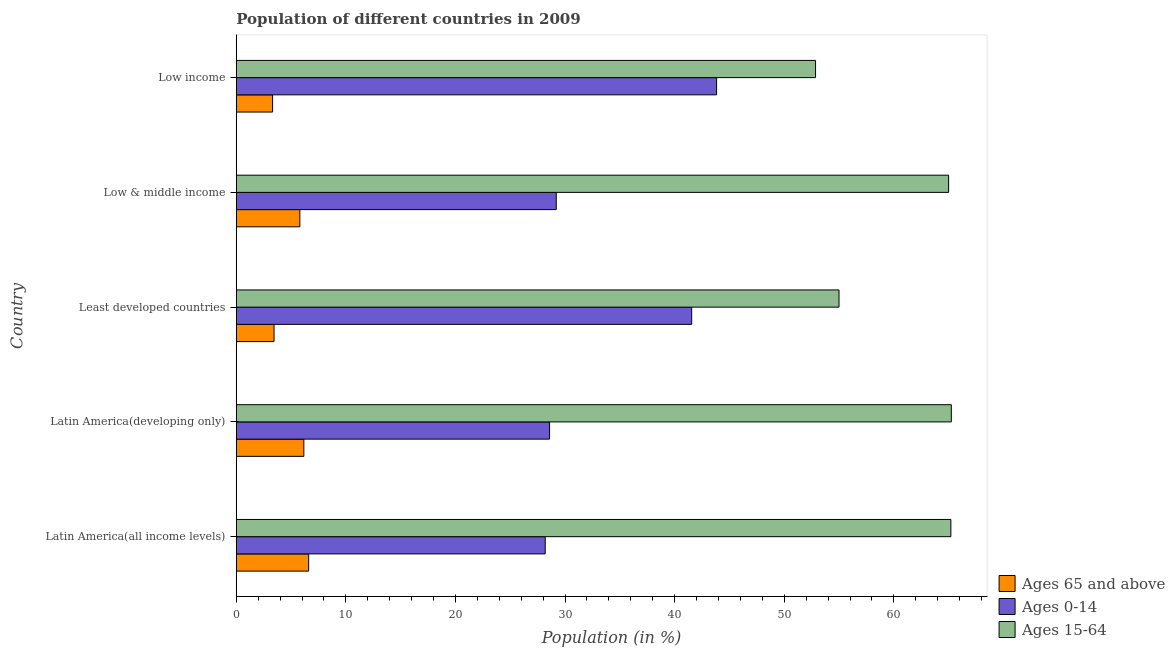Are the number of bars per tick equal to the number of legend labels?
Your answer should be compact. Yes. How many bars are there on the 3rd tick from the bottom?
Provide a short and direct response. 3. What is the label of the 5th group of bars from the top?
Your answer should be very brief. Latin America(all income levels). What is the percentage of population within the age-group 15-64 in Latin America(all income levels)?
Your answer should be compact. 65.2. Across all countries, what is the maximum percentage of population within the age-group 15-64?
Provide a succinct answer. 65.24. Across all countries, what is the minimum percentage of population within the age-group of 65 and above?
Offer a very short reply. 3.32. In which country was the percentage of population within the age-group 15-64 minimum?
Make the answer very short. Low income. What is the total percentage of population within the age-group 0-14 in the graph?
Your answer should be compact. 171.36. What is the difference between the percentage of population within the age-group 0-14 in Latin America(developing only) and that in Low income?
Ensure brevity in your answer.  -15.24. What is the difference between the percentage of population within the age-group 15-64 in Low & middle income and the percentage of population within the age-group of 65 and above in Latin America(developing only)?
Offer a very short reply. 58.83. What is the average percentage of population within the age-group 0-14 per country?
Offer a terse response. 34.27. What is the difference between the percentage of population within the age-group 0-14 and percentage of population within the age-group 15-64 in Latin America(all income levels)?
Make the answer very short. -37.01. What is the ratio of the percentage of population within the age-group 0-14 in Least developed countries to that in Low & middle income?
Provide a succinct answer. 1.42. Is the percentage of population within the age-group 0-14 in Latin America(all income levels) less than that in Low income?
Ensure brevity in your answer.  Yes. Is the difference between the percentage of population within the age-group of 65 and above in Latin America(developing only) and Low income greater than the difference between the percentage of population within the age-group 15-64 in Latin America(developing only) and Low income?
Keep it short and to the point. No. What is the difference between the highest and the second highest percentage of population within the age-group of 65 and above?
Keep it short and to the point. 0.44. What is the difference between the highest and the lowest percentage of population within the age-group of 65 and above?
Your answer should be very brief. 3.29. In how many countries, is the percentage of population within the age-group 15-64 greater than the average percentage of population within the age-group 15-64 taken over all countries?
Your answer should be very brief. 3. What does the 2nd bar from the top in Latin America(developing only) represents?
Give a very brief answer. Ages 0-14. What does the 1st bar from the bottom in Least developed countries represents?
Your response must be concise. Ages 65 and above. How many bars are there?
Your answer should be very brief. 15. Are all the bars in the graph horizontal?
Provide a succinct answer. Yes. How many countries are there in the graph?
Keep it short and to the point. 5. Does the graph contain any zero values?
Your answer should be compact. No. Where does the legend appear in the graph?
Offer a very short reply. Bottom right. What is the title of the graph?
Provide a succinct answer. Population of different countries in 2009. Does "Social insurance" appear as one of the legend labels in the graph?
Provide a short and direct response. No. What is the label or title of the X-axis?
Provide a short and direct response. Population (in %). What is the label or title of the Y-axis?
Offer a terse response. Country. What is the Population (in %) of Ages 65 and above in Latin America(all income levels)?
Keep it short and to the point. 6.61. What is the Population (in %) in Ages 0-14 in Latin America(all income levels)?
Give a very brief answer. 28.19. What is the Population (in %) in Ages 15-64 in Latin America(all income levels)?
Make the answer very short. 65.2. What is the Population (in %) in Ages 65 and above in Latin America(developing only)?
Offer a terse response. 6.17. What is the Population (in %) of Ages 0-14 in Latin America(developing only)?
Make the answer very short. 28.59. What is the Population (in %) of Ages 15-64 in Latin America(developing only)?
Provide a succinct answer. 65.24. What is the Population (in %) of Ages 65 and above in Least developed countries?
Offer a terse response. 3.45. What is the Population (in %) of Ages 0-14 in Least developed countries?
Offer a very short reply. 41.55. What is the Population (in %) of Ages 15-64 in Least developed countries?
Ensure brevity in your answer.  55. What is the Population (in %) in Ages 65 and above in Low & middle income?
Provide a short and direct response. 5.8. What is the Population (in %) in Ages 0-14 in Low & middle income?
Make the answer very short. 29.2. What is the Population (in %) of Ages 15-64 in Low & middle income?
Give a very brief answer. 65. What is the Population (in %) of Ages 65 and above in Low income?
Make the answer very short. 3.32. What is the Population (in %) in Ages 0-14 in Low income?
Ensure brevity in your answer.  43.83. What is the Population (in %) in Ages 15-64 in Low income?
Provide a short and direct response. 52.86. Across all countries, what is the maximum Population (in %) of Ages 65 and above?
Ensure brevity in your answer.  6.61. Across all countries, what is the maximum Population (in %) of Ages 0-14?
Ensure brevity in your answer.  43.83. Across all countries, what is the maximum Population (in %) of Ages 15-64?
Provide a short and direct response. 65.24. Across all countries, what is the minimum Population (in %) of Ages 65 and above?
Your answer should be compact. 3.32. Across all countries, what is the minimum Population (in %) in Ages 0-14?
Your answer should be compact. 28.19. Across all countries, what is the minimum Population (in %) in Ages 15-64?
Keep it short and to the point. 52.86. What is the total Population (in %) in Ages 65 and above in the graph?
Keep it short and to the point. 25.34. What is the total Population (in %) of Ages 0-14 in the graph?
Make the answer very short. 171.36. What is the total Population (in %) of Ages 15-64 in the graph?
Make the answer very short. 303.3. What is the difference between the Population (in %) of Ages 65 and above in Latin America(all income levels) and that in Latin America(developing only)?
Make the answer very short. 0.44. What is the difference between the Population (in %) of Ages 0-14 in Latin America(all income levels) and that in Latin America(developing only)?
Provide a short and direct response. -0.4. What is the difference between the Population (in %) of Ages 15-64 in Latin America(all income levels) and that in Latin America(developing only)?
Your answer should be compact. -0.04. What is the difference between the Population (in %) in Ages 65 and above in Latin America(all income levels) and that in Least developed countries?
Your response must be concise. 3.16. What is the difference between the Population (in %) of Ages 0-14 in Latin America(all income levels) and that in Least developed countries?
Your response must be concise. -13.36. What is the difference between the Population (in %) in Ages 15-64 in Latin America(all income levels) and that in Least developed countries?
Your response must be concise. 10.2. What is the difference between the Population (in %) in Ages 65 and above in Latin America(all income levels) and that in Low & middle income?
Your answer should be very brief. 0.8. What is the difference between the Population (in %) in Ages 0-14 in Latin America(all income levels) and that in Low & middle income?
Keep it short and to the point. -1.01. What is the difference between the Population (in %) in Ages 15-64 in Latin America(all income levels) and that in Low & middle income?
Keep it short and to the point. 0.2. What is the difference between the Population (in %) in Ages 65 and above in Latin America(all income levels) and that in Low income?
Give a very brief answer. 3.29. What is the difference between the Population (in %) in Ages 0-14 in Latin America(all income levels) and that in Low income?
Ensure brevity in your answer.  -15.64. What is the difference between the Population (in %) of Ages 15-64 in Latin America(all income levels) and that in Low income?
Make the answer very short. 12.35. What is the difference between the Population (in %) in Ages 65 and above in Latin America(developing only) and that in Least developed countries?
Keep it short and to the point. 2.72. What is the difference between the Population (in %) of Ages 0-14 in Latin America(developing only) and that in Least developed countries?
Provide a succinct answer. -12.97. What is the difference between the Population (in %) in Ages 15-64 in Latin America(developing only) and that in Least developed countries?
Offer a terse response. 10.25. What is the difference between the Population (in %) in Ages 65 and above in Latin America(developing only) and that in Low & middle income?
Give a very brief answer. 0.37. What is the difference between the Population (in %) of Ages 0-14 in Latin America(developing only) and that in Low & middle income?
Your answer should be compact. -0.61. What is the difference between the Population (in %) of Ages 15-64 in Latin America(developing only) and that in Low & middle income?
Provide a short and direct response. 0.25. What is the difference between the Population (in %) of Ages 65 and above in Latin America(developing only) and that in Low income?
Provide a succinct answer. 2.85. What is the difference between the Population (in %) in Ages 0-14 in Latin America(developing only) and that in Low income?
Offer a very short reply. -15.24. What is the difference between the Population (in %) in Ages 15-64 in Latin America(developing only) and that in Low income?
Ensure brevity in your answer.  12.39. What is the difference between the Population (in %) of Ages 65 and above in Least developed countries and that in Low & middle income?
Provide a short and direct response. -2.35. What is the difference between the Population (in %) of Ages 0-14 in Least developed countries and that in Low & middle income?
Offer a very short reply. 12.36. What is the difference between the Population (in %) in Ages 15-64 in Least developed countries and that in Low & middle income?
Provide a succinct answer. -10. What is the difference between the Population (in %) of Ages 65 and above in Least developed countries and that in Low income?
Ensure brevity in your answer.  0.13. What is the difference between the Population (in %) in Ages 0-14 in Least developed countries and that in Low income?
Offer a very short reply. -2.27. What is the difference between the Population (in %) of Ages 15-64 in Least developed countries and that in Low income?
Offer a terse response. 2.14. What is the difference between the Population (in %) of Ages 65 and above in Low & middle income and that in Low income?
Offer a terse response. 2.49. What is the difference between the Population (in %) of Ages 0-14 in Low & middle income and that in Low income?
Your answer should be compact. -14.63. What is the difference between the Population (in %) in Ages 15-64 in Low & middle income and that in Low income?
Your answer should be compact. 12.14. What is the difference between the Population (in %) of Ages 65 and above in Latin America(all income levels) and the Population (in %) of Ages 0-14 in Latin America(developing only)?
Offer a very short reply. -21.98. What is the difference between the Population (in %) in Ages 65 and above in Latin America(all income levels) and the Population (in %) in Ages 15-64 in Latin America(developing only)?
Offer a terse response. -58.64. What is the difference between the Population (in %) of Ages 0-14 in Latin America(all income levels) and the Population (in %) of Ages 15-64 in Latin America(developing only)?
Keep it short and to the point. -37.05. What is the difference between the Population (in %) of Ages 65 and above in Latin America(all income levels) and the Population (in %) of Ages 0-14 in Least developed countries?
Keep it short and to the point. -34.95. What is the difference between the Population (in %) of Ages 65 and above in Latin America(all income levels) and the Population (in %) of Ages 15-64 in Least developed countries?
Your response must be concise. -48.39. What is the difference between the Population (in %) of Ages 0-14 in Latin America(all income levels) and the Population (in %) of Ages 15-64 in Least developed countries?
Give a very brief answer. -26.81. What is the difference between the Population (in %) of Ages 65 and above in Latin America(all income levels) and the Population (in %) of Ages 0-14 in Low & middle income?
Provide a short and direct response. -22.59. What is the difference between the Population (in %) of Ages 65 and above in Latin America(all income levels) and the Population (in %) of Ages 15-64 in Low & middle income?
Provide a succinct answer. -58.39. What is the difference between the Population (in %) of Ages 0-14 in Latin America(all income levels) and the Population (in %) of Ages 15-64 in Low & middle income?
Your answer should be compact. -36.81. What is the difference between the Population (in %) in Ages 65 and above in Latin America(all income levels) and the Population (in %) in Ages 0-14 in Low income?
Give a very brief answer. -37.22. What is the difference between the Population (in %) in Ages 65 and above in Latin America(all income levels) and the Population (in %) in Ages 15-64 in Low income?
Give a very brief answer. -46.25. What is the difference between the Population (in %) of Ages 0-14 in Latin America(all income levels) and the Population (in %) of Ages 15-64 in Low income?
Provide a succinct answer. -24.67. What is the difference between the Population (in %) in Ages 65 and above in Latin America(developing only) and the Population (in %) in Ages 0-14 in Least developed countries?
Provide a succinct answer. -35.39. What is the difference between the Population (in %) of Ages 65 and above in Latin America(developing only) and the Population (in %) of Ages 15-64 in Least developed countries?
Provide a short and direct response. -48.83. What is the difference between the Population (in %) in Ages 0-14 in Latin America(developing only) and the Population (in %) in Ages 15-64 in Least developed countries?
Provide a succinct answer. -26.41. What is the difference between the Population (in %) of Ages 65 and above in Latin America(developing only) and the Population (in %) of Ages 0-14 in Low & middle income?
Ensure brevity in your answer.  -23.03. What is the difference between the Population (in %) in Ages 65 and above in Latin America(developing only) and the Population (in %) in Ages 15-64 in Low & middle income?
Provide a short and direct response. -58.83. What is the difference between the Population (in %) in Ages 0-14 in Latin America(developing only) and the Population (in %) in Ages 15-64 in Low & middle income?
Keep it short and to the point. -36.41. What is the difference between the Population (in %) of Ages 65 and above in Latin America(developing only) and the Population (in %) of Ages 0-14 in Low income?
Make the answer very short. -37.66. What is the difference between the Population (in %) of Ages 65 and above in Latin America(developing only) and the Population (in %) of Ages 15-64 in Low income?
Offer a very short reply. -46.69. What is the difference between the Population (in %) in Ages 0-14 in Latin America(developing only) and the Population (in %) in Ages 15-64 in Low income?
Your answer should be very brief. -24.27. What is the difference between the Population (in %) of Ages 65 and above in Least developed countries and the Population (in %) of Ages 0-14 in Low & middle income?
Your answer should be compact. -25.75. What is the difference between the Population (in %) of Ages 65 and above in Least developed countries and the Population (in %) of Ages 15-64 in Low & middle income?
Provide a short and direct response. -61.55. What is the difference between the Population (in %) in Ages 0-14 in Least developed countries and the Population (in %) in Ages 15-64 in Low & middle income?
Your answer should be very brief. -23.44. What is the difference between the Population (in %) of Ages 65 and above in Least developed countries and the Population (in %) of Ages 0-14 in Low income?
Keep it short and to the point. -40.38. What is the difference between the Population (in %) in Ages 65 and above in Least developed countries and the Population (in %) in Ages 15-64 in Low income?
Keep it short and to the point. -49.41. What is the difference between the Population (in %) of Ages 0-14 in Least developed countries and the Population (in %) of Ages 15-64 in Low income?
Offer a terse response. -11.3. What is the difference between the Population (in %) of Ages 65 and above in Low & middle income and the Population (in %) of Ages 0-14 in Low income?
Your answer should be very brief. -38.03. What is the difference between the Population (in %) in Ages 65 and above in Low & middle income and the Population (in %) in Ages 15-64 in Low income?
Give a very brief answer. -47.05. What is the difference between the Population (in %) of Ages 0-14 in Low & middle income and the Population (in %) of Ages 15-64 in Low income?
Your answer should be very brief. -23.66. What is the average Population (in %) in Ages 65 and above per country?
Provide a short and direct response. 5.07. What is the average Population (in %) of Ages 0-14 per country?
Offer a terse response. 34.27. What is the average Population (in %) of Ages 15-64 per country?
Offer a terse response. 60.66. What is the difference between the Population (in %) in Ages 65 and above and Population (in %) in Ages 0-14 in Latin America(all income levels)?
Give a very brief answer. -21.58. What is the difference between the Population (in %) in Ages 65 and above and Population (in %) in Ages 15-64 in Latin America(all income levels)?
Your response must be concise. -58.6. What is the difference between the Population (in %) in Ages 0-14 and Population (in %) in Ages 15-64 in Latin America(all income levels)?
Ensure brevity in your answer.  -37.01. What is the difference between the Population (in %) of Ages 65 and above and Population (in %) of Ages 0-14 in Latin America(developing only)?
Keep it short and to the point. -22.42. What is the difference between the Population (in %) in Ages 65 and above and Population (in %) in Ages 15-64 in Latin America(developing only)?
Your response must be concise. -59.08. What is the difference between the Population (in %) of Ages 0-14 and Population (in %) of Ages 15-64 in Latin America(developing only)?
Provide a short and direct response. -36.66. What is the difference between the Population (in %) in Ages 65 and above and Population (in %) in Ages 0-14 in Least developed countries?
Your response must be concise. -38.11. What is the difference between the Population (in %) in Ages 65 and above and Population (in %) in Ages 15-64 in Least developed countries?
Your answer should be very brief. -51.55. What is the difference between the Population (in %) in Ages 0-14 and Population (in %) in Ages 15-64 in Least developed countries?
Your answer should be very brief. -13.44. What is the difference between the Population (in %) of Ages 65 and above and Population (in %) of Ages 0-14 in Low & middle income?
Provide a short and direct response. -23.4. What is the difference between the Population (in %) of Ages 65 and above and Population (in %) of Ages 15-64 in Low & middle income?
Your answer should be compact. -59.2. What is the difference between the Population (in %) in Ages 0-14 and Population (in %) in Ages 15-64 in Low & middle income?
Your answer should be very brief. -35.8. What is the difference between the Population (in %) in Ages 65 and above and Population (in %) in Ages 0-14 in Low income?
Make the answer very short. -40.51. What is the difference between the Population (in %) in Ages 65 and above and Population (in %) in Ages 15-64 in Low income?
Give a very brief answer. -49.54. What is the difference between the Population (in %) in Ages 0-14 and Population (in %) in Ages 15-64 in Low income?
Your answer should be very brief. -9.03. What is the ratio of the Population (in %) of Ages 65 and above in Latin America(all income levels) to that in Latin America(developing only)?
Offer a terse response. 1.07. What is the ratio of the Population (in %) in Ages 0-14 in Latin America(all income levels) to that in Latin America(developing only)?
Make the answer very short. 0.99. What is the ratio of the Population (in %) of Ages 15-64 in Latin America(all income levels) to that in Latin America(developing only)?
Your response must be concise. 1. What is the ratio of the Population (in %) of Ages 65 and above in Latin America(all income levels) to that in Least developed countries?
Keep it short and to the point. 1.92. What is the ratio of the Population (in %) of Ages 0-14 in Latin America(all income levels) to that in Least developed countries?
Provide a succinct answer. 0.68. What is the ratio of the Population (in %) of Ages 15-64 in Latin America(all income levels) to that in Least developed countries?
Offer a terse response. 1.19. What is the ratio of the Population (in %) in Ages 65 and above in Latin America(all income levels) to that in Low & middle income?
Your answer should be very brief. 1.14. What is the ratio of the Population (in %) in Ages 0-14 in Latin America(all income levels) to that in Low & middle income?
Keep it short and to the point. 0.97. What is the ratio of the Population (in %) in Ages 65 and above in Latin America(all income levels) to that in Low income?
Offer a terse response. 1.99. What is the ratio of the Population (in %) of Ages 0-14 in Latin America(all income levels) to that in Low income?
Provide a short and direct response. 0.64. What is the ratio of the Population (in %) of Ages 15-64 in Latin America(all income levels) to that in Low income?
Your response must be concise. 1.23. What is the ratio of the Population (in %) of Ages 65 and above in Latin America(developing only) to that in Least developed countries?
Keep it short and to the point. 1.79. What is the ratio of the Population (in %) in Ages 0-14 in Latin America(developing only) to that in Least developed countries?
Keep it short and to the point. 0.69. What is the ratio of the Population (in %) in Ages 15-64 in Latin America(developing only) to that in Least developed countries?
Your answer should be very brief. 1.19. What is the ratio of the Population (in %) in Ages 65 and above in Latin America(developing only) to that in Low & middle income?
Provide a short and direct response. 1.06. What is the ratio of the Population (in %) in Ages 0-14 in Latin America(developing only) to that in Low & middle income?
Your response must be concise. 0.98. What is the ratio of the Population (in %) in Ages 65 and above in Latin America(developing only) to that in Low income?
Your answer should be compact. 1.86. What is the ratio of the Population (in %) in Ages 0-14 in Latin America(developing only) to that in Low income?
Offer a very short reply. 0.65. What is the ratio of the Population (in %) in Ages 15-64 in Latin America(developing only) to that in Low income?
Keep it short and to the point. 1.23. What is the ratio of the Population (in %) in Ages 65 and above in Least developed countries to that in Low & middle income?
Your response must be concise. 0.59. What is the ratio of the Population (in %) in Ages 0-14 in Least developed countries to that in Low & middle income?
Your answer should be very brief. 1.42. What is the ratio of the Population (in %) in Ages 15-64 in Least developed countries to that in Low & middle income?
Your response must be concise. 0.85. What is the ratio of the Population (in %) of Ages 65 and above in Least developed countries to that in Low income?
Make the answer very short. 1.04. What is the ratio of the Population (in %) in Ages 0-14 in Least developed countries to that in Low income?
Your response must be concise. 0.95. What is the ratio of the Population (in %) of Ages 15-64 in Least developed countries to that in Low income?
Offer a terse response. 1.04. What is the ratio of the Population (in %) of Ages 65 and above in Low & middle income to that in Low income?
Make the answer very short. 1.75. What is the ratio of the Population (in %) of Ages 0-14 in Low & middle income to that in Low income?
Ensure brevity in your answer.  0.67. What is the ratio of the Population (in %) of Ages 15-64 in Low & middle income to that in Low income?
Offer a terse response. 1.23. What is the difference between the highest and the second highest Population (in %) in Ages 65 and above?
Provide a succinct answer. 0.44. What is the difference between the highest and the second highest Population (in %) of Ages 0-14?
Make the answer very short. 2.27. What is the difference between the highest and the second highest Population (in %) of Ages 15-64?
Offer a very short reply. 0.04. What is the difference between the highest and the lowest Population (in %) of Ages 65 and above?
Make the answer very short. 3.29. What is the difference between the highest and the lowest Population (in %) of Ages 0-14?
Your response must be concise. 15.64. What is the difference between the highest and the lowest Population (in %) in Ages 15-64?
Provide a succinct answer. 12.39. 